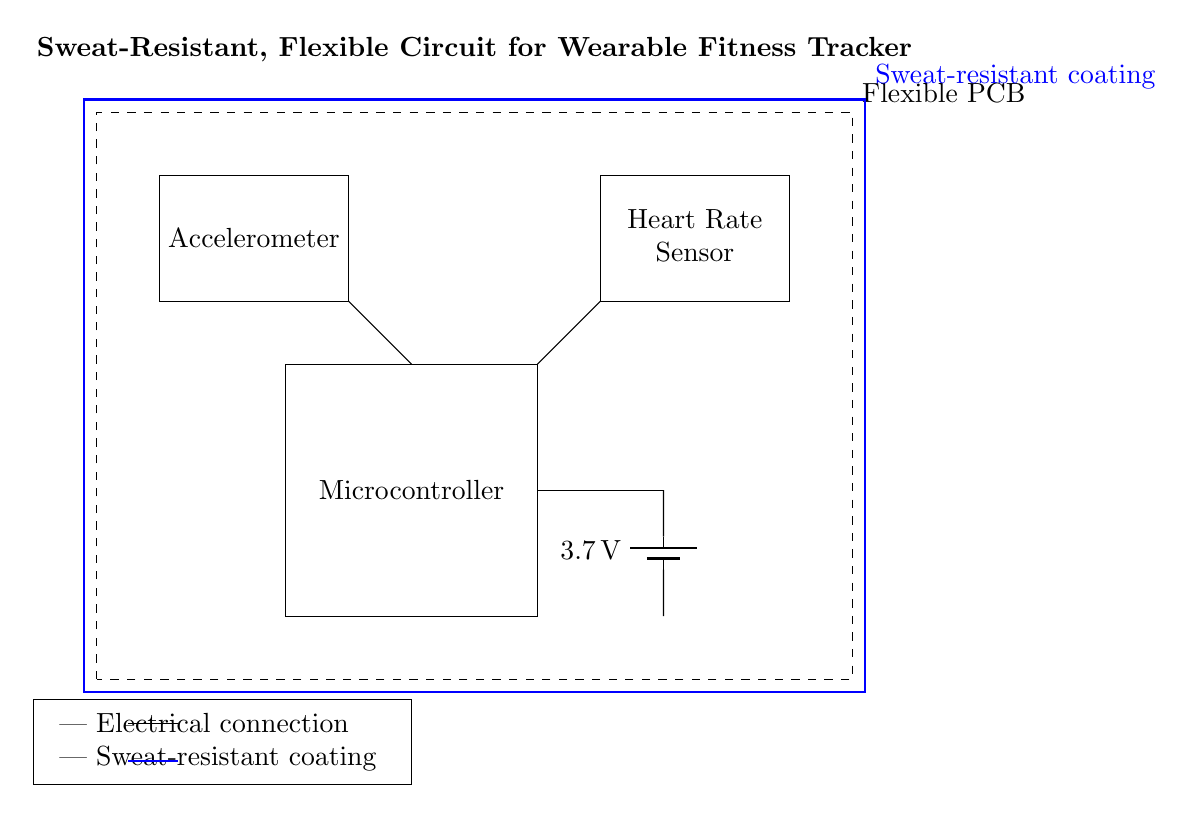What components are in this circuit? The circuit contains a microcontroller, accelerometer, heart rate sensor, and a battery. These are visually represented as rectangles or items in the diagram.
Answer: Microcontroller, accelerometer, heart rate sensor, battery What is the voltage of the battery? The battery in the circuit is labeled as providing a voltage of 3.7 volts, as indicated on the battery symbol in the diagram.
Answer: 3.7 volts How is the heart rate sensor connected? The connection from the heart rate sensor to the rest of the circuit is indicated by a line leading to another component, which helps to establish its role in the circuit.
Answer: Connected to the microcontroller What type of circuit is used for this wearable device? The circuit is a flexible circuit designed specifically for wearable fitness trackers, which is highlighted by the dashed rectangle and the accompanying label in the diagram.
Answer: Flexible circuit What feature protects the circuit from sweat? The circuit is coated with a sweat-resistant coating, which is depicted as a blue rectangle surrounding the entire circuit, emphasizing its protective function.
Answer: Sweat-resistant coating Why might flexibility be important in this design? Flexibility is crucial for comfort and wearability in fitness trackers, allowing the device to conform to the body while maintaining functionality, which is inferred from the mention of a flexible PCB in the diagram.
Answer: Comfort and wearability 